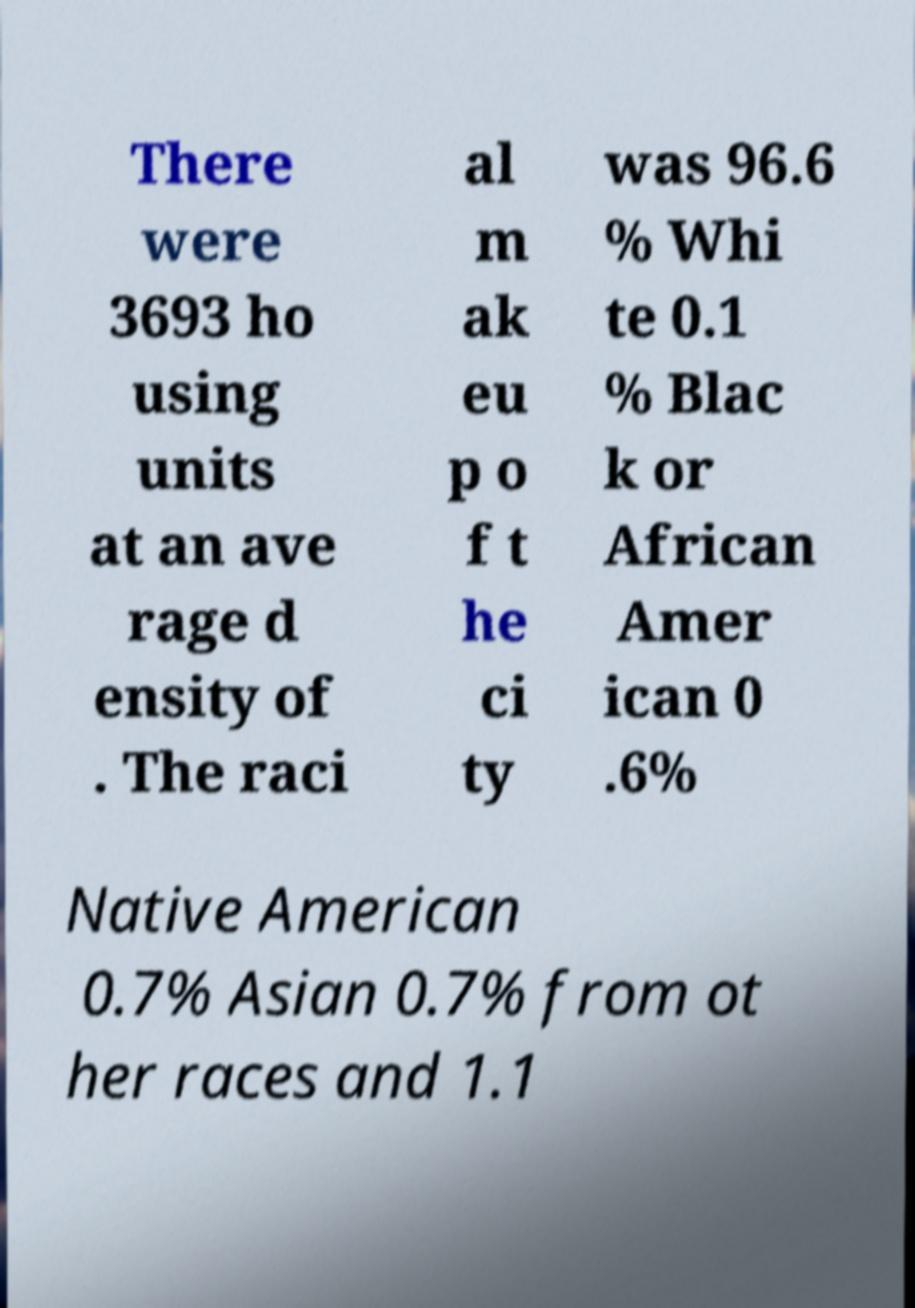What messages or text are displayed in this image? I need them in a readable, typed format. There were 3693 ho using units at an ave rage d ensity of . The raci al m ak eu p o f t he ci ty was 96.6 % Whi te 0.1 % Blac k or African Amer ican 0 .6% Native American 0.7% Asian 0.7% from ot her races and 1.1 